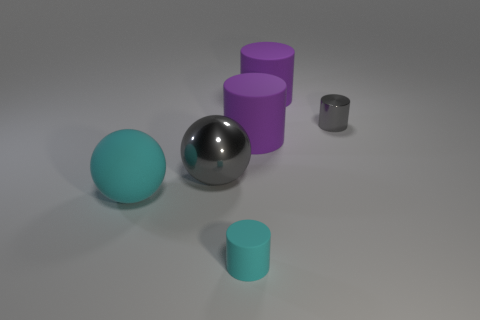Does the rubber thing that is left of the large shiny object have the same color as the tiny rubber thing?
Offer a terse response. Yes. What color is the thing that is both to the right of the cyan ball and in front of the large gray ball?
Your answer should be very brief. Cyan. There is a ball that is on the left side of the metallic ball; what is it made of?
Your answer should be compact. Rubber. What is the size of the metallic cylinder?
Give a very brief answer. Small. What number of blue things are either large spheres or tiny metal things?
Ensure brevity in your answer.  0. What size is the gray object that is right of the tiny cylinder in front of the large gray object?
Keep it short and to the point. Small. Do the tiny metal cylinder and the big thing on the left side of the big metallic sphere have the same color?
Give a very brief answer. No. How many other objects are there of the same material as the gray sphere?
Offer a very short reply. 1. What is the shape of the tiny gray object that is the same material as the gray sphere?
Offer a terse response. Cylinder. Are there any other things that have the same color as the metallic cylinder?
Offer a terse response. Yes. 